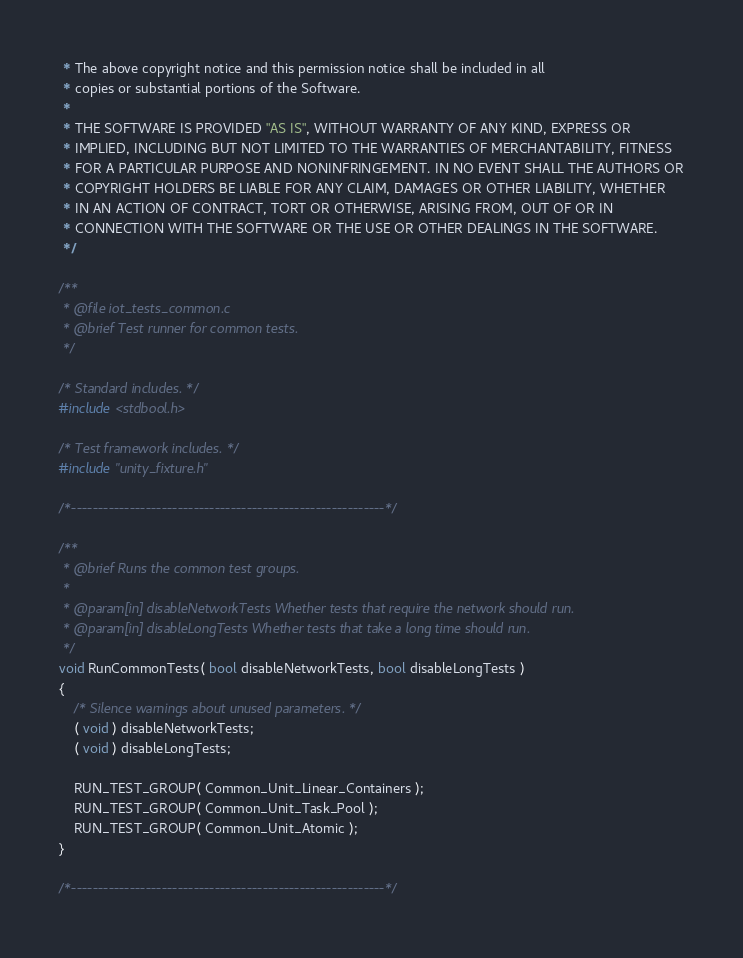<code> <loc_0><loc_0><loc_500><loc_500><_C_> * The above copyright notice and this permission notice shall be included in all
 * copies or substantial portions of the Software.
 *
 * THE SOFTWARE IS PROVIDED "AS IS", WITHOUT WARRANTY OF ANY KIND, EXPRESS OR
 * IMPLIED, INCLUDING BUT NOT LIMITED TO THE WARRANTIES OF MERCHANTABILITY, FITNESS
 * FOR A PARTICULAR PURPOSE AND NONINFRINGEMENT. IN NO EVENT SHALL THE AUTHORS OR
 * COPYRIGHT HOLDERS BE LIABLE FOR ANY CLAIM, DAMAGES OR OTHER LIABILITY, WHETHER
 * IN AN ACTION OF CONTRACT, TORT OR OTHERWISE, ARISING FROM, OUT OF OR IN
 * CONNECTION WITH THE SOFTWARE OR THE USE OR OTHER DEALINGS IN THE SOFTWARE.
 */

/**
 * @file iot_tests_common.c
 * @brief Test runner for common tests.
 */

/* Standard includes. */
#include <stdbool.h>

/* Test framework includes. */
#include "unity_fixture.h"

/*-----------------------------------------------------------*/

/**
 * @brief Runs the common test groups.
 *
 * @param[in] disableNetworkTests Whether tests that require the network should run.
 * @param[in] disableLongTests Whether tests that take a long time should run.
 */
void RunCommonTests( bool disableNetworkTests, bool disableLongTests )
{
    /* Silence warnings about unused parameters. */
    ( void ) disableNetworkTests;
    ( void ) disableLongTests;

    RUN_TEST_GROUP( Common_Unit_Linear_Containers );
    RUN_TEST_GROUP( Common_Unit_Task_Pool );
    RUN_TEST_GROUP( Common_Unit_Atomic );
}

/*-----------------------------------------------------------*/
</code> 